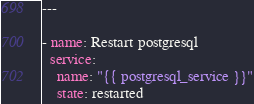<code> <loc_0><loc_0><loc_500><loc_500><_YAML_>---

- name: Restart postgresql
  service:
    name: "{{ postgresql_service }}"
    state: restarted
</code> 